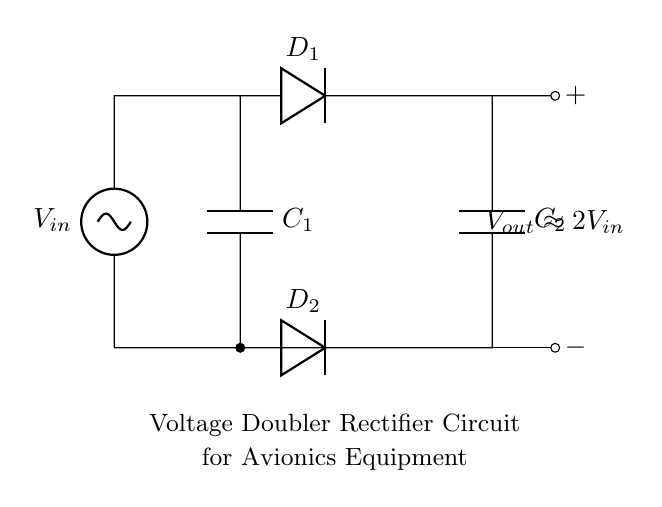What is the type of circuit depicted? The circuit is a voltage doubler rectifier circuit, indicated by its configuration to double the input voltage utilizing capacitors and diodes.
Answer: voltage doubler rectifier How many capacitors are in the circuit? There are two capacitors labeled as C1 and C2 within the circuit, which are used to store charge and contribute to the voltage doubling effect.
Answer: 2 What is the role of D1? D1 is used as a rectifying diode, allowing current to flow in one direction during the charging phase of C2, thereby helping to convert AC to DC.
Answer: rectifying diode What is the output voltage relative to the input voltage? The output voltage is approximately twice the input voltage, as indicated by the label in the diagram stating Vout is about 2Vin.
Answer: 2Vin What is the total number of diodes in the circuit? The circuit consists of two diodes, D1 and D2, which work together to create the voltage doubler effect by alternating the current flow.
Answer: 2 What happens if one capacitor fails? If one capacitor fails, it will affect the ability of the circuit to double the voltage since both capacitors are essential for charge storage during the operation of the circuit.
Answer: voltage doubling affected What is the function of C1 and C2 in this circuit? C1 and C2 serve to store and transfer charge, with C1 charging from the input and C2 providing the output, which results in a higher output voltage.
Answer: charge storage and transfer 